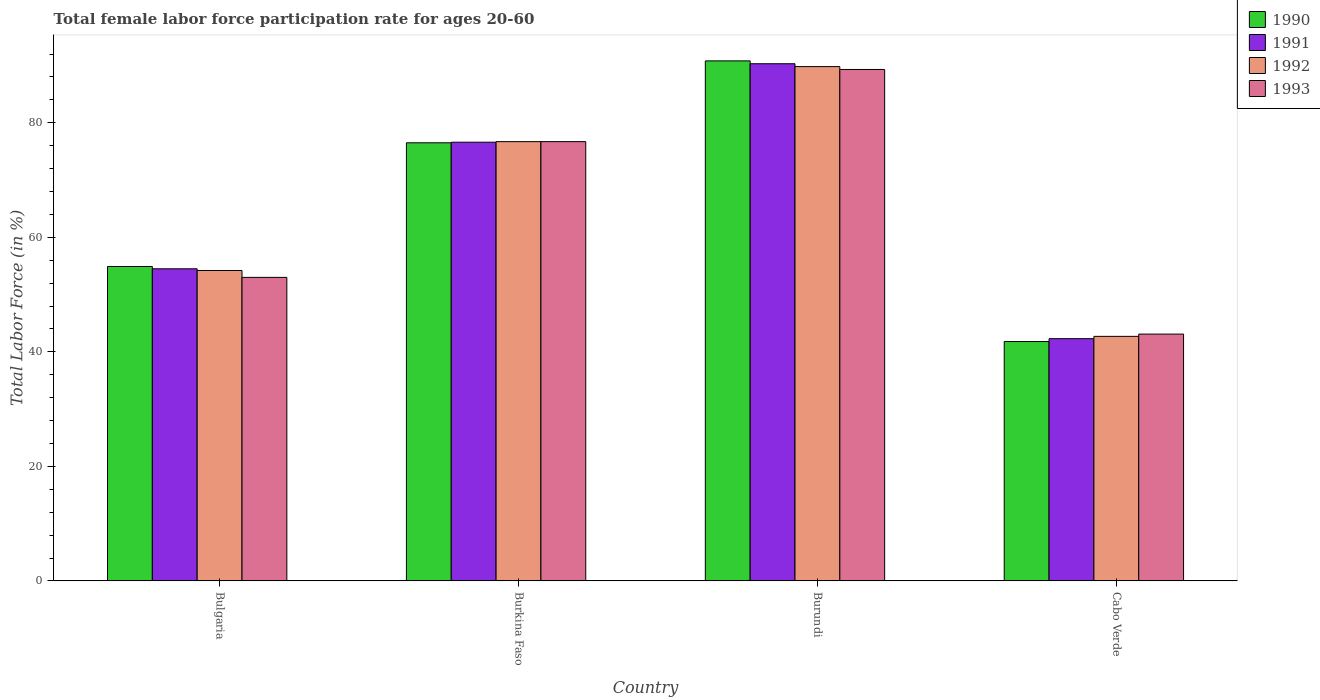Are the number of bars per tick equal to the number of legend labels?
Your answer should be very brief. Yes. In how many cases, is the number of bars for a given country not equal to the number of legend labels?
Ensure brevity in your answer.  0. What is the female labor force participation rate in 1991 in Cabo Verde?
Your response must be concise. 42.3. Across all countries, what is the maximum female labor force participation rate in 1993?
Your answer should be compact. 89.3. Across all countries, what is the minimum female labor force participation rate in 1993?
Offer a very short reply. 43.1. In which country was the female labor force participation rate in 1992 maximum?
Ensure brevity in your answer.  Burundi. In which country was the female labor force participation rate in 1992 minimum?
Your answer should be very brief. Cabo Verde. What is the total female labor force participation rate in 1992 in the graph?
Your response must be concise. 263.4. What is the difference between the female labor force participation rate in 1992 in Burkina Faso and that in Cabo Verde?
Ensure brevity in your answer.  34. What is the difference between the female labor force participation rate in 1992 in Bulgaria and the female labor force participation rate in 1993 in Burkina Faso?
Keep it short and to the point. -22.5. What is the average female labor force participation rate in 1991 per country?
Ensure brevity in your answer.  65.93. In how many countries, is the female labor force participation rate in 1990 greater than 20 %?
Offer a very short reply. 4. What is the ratio of the female labor force participation rate in 1992 in Burkina Faso to that in Burundi?
Ensure brevity in your answer.  0.85. What is the difference between the highest and the second highest female labor force participation rate in 1991?
Keep it short and to the point. 13.7. What is the difference between the highest and the lowest female labor force participation rate in 1993?
Offer a terse response. 46.2. In how many countries, is the female labor force participation rate in 1993 greater than the average female labor force participation rate in 1993 taken over all countries?
Provide a succinct answer. 2. Is the sum of the female labor force participation rate in 1990 in Bulgaria and Burundi greater than the maximum female labor force participation rate in 1991 across all countries?
Make the answer very short. Yes. What does the 1st bar from the left in Bulgaria represents?
Your response must be concise. 1990. What does the 3rd bar from the right in Bulgaria represents?
Ensure brevity in your answer.  1991. Is it the case that in every country, the sum of the female labor force participation rate in 1993 and female labor force participation rate in 1990 is greater than the female labor force participation rate in 1991?
Keep it short and to the point. Yes. How many bars are there?
Keep it short and to the point. 16. How many countries are there in the graph?
Give a very brief answer. 4. What is the difference between two consecutive major ticks on the Y-axis?
Your response must be concise. 20. Where does the legend appear in the graph?
Your answer should be very brief. Top right. How are the legend labels stacked?
Offer a terse response. Vertical. What is the title of the graph?
Your answer should be compact. Total female labor force participation rate for ages 20-60. Does "2009" appear as one of the legend labels in the graph?
Your answer should be very brief. No. What is the Total Labor Force (in %) in 1990 in Bulgaria?
Keep it short and to the point. 54.9. What is the Total Labor Force (in %) of 1991 in Bulgaria?
Keep it short and to the point. 54.5. What is the Total Labor Force (in %) of 1992 in Bulgaria?
Your answer should be very brief. 54.2. What is the Total Labor Force (in %) of 1993 in Bulgaria?
Ensure brevity in your answer.  53. What is the Total Labor Force (in %) of 1990 in Burkina Faso?
Your answer should be compact. 76.5. What is the Total Labor Force (in %) of 1991 in Burkina Faso?
Provide a short and direct response. 76.6. What is the Total Labor Force (in %) of 1992 in Burkina Faso?
Keep it short and to the point. 76.7. What is the Total Labor Force (in %) of 1993 in Burkina Faso?
Your answer should be compact. 76.7. What is the Total Labor Force (in %) of 1990 in Burundi?
Provide a succinct answer. 90.8. What is the Total Labor Force (in %) of 1991 in Burundi?
Ensure brevity in your answer.  90.3. What is the Total Labor Force (in %) of 1992 in Burundi?
Give a very brief answer. 89.8. What is the Total Labor Force (in %) of 1993 in Burundi?
Your response must be concise. 89.3. What is the Total Labor Force (in %) of 1990 in Cabo Verde?
Give a very brief answer. 41.8. What is the Total Labor Force (in %) in 1991 in Cabo Verde?
Your answer should be very brief. 42.3. What is the Total Labor Force (in %) in 1992 in Cabo Verde?
Ensure brevity in your answer.  42.7. What is the Total Labor Force (in %) of 1993 in Cabo Verde?
Offer a terse response. 43.1. Across all countries, what is the maximum Total Labor Force (in %) in 1990?
Give a very brief answer. 90.8. Across all countries, what is the maximum Total Labor Force (in %) in 1991?
Ensure brevity in your answer.  90.3. Across all countries, what is the maximum Total Labor Force (in %) in 1992?
Keep it short and to the point. 89.8. Across all countries, what is the maximum Total Labor Force (in %) of 1993?
Offer a terse response. 89.3. Across all countries, what is the minimum Total Labor Force (in %) in 1990?
Make the answer very short. 41.8. Across all countries, what is the minimum Total Labor Force (in %) of 1991?
Offer a very short reply. 42.3. Across all countries, what is the minimum Total Labor Force (in %) of 1992?
Give a very brief answer. 42.7. Across all countries, what is the minimum Total Labor Force (in %) of 1993?
Offer a very short reply. 43.1. What is the total Total Labor Force (in %) of 1990 in the graph?
Offer a terse response. 264. What is the total Total Labor Force (in %) of 1991 in the graph?
Provide a succinct answer. 263.7. What is the total Total Labor Force (in %) in 1992 in the graph?
Offer a very short reply. 263.4. What is the total Total Labor Force (in %) of 1993 in the graph?
Your answer should be compact. 262.1. What is the difference between the Total Labor Force (in %) of 1990 in Bulgaria and that in Burkina Faso?
Offer a very short reply. -21.6. What is the difference between the Total Labor Force (in %) in 1991 in Bulgaria and that in Burkina Faso?
Your answer should be very brief. -22.1. What is the difference between the Total Labor Force (in %) in 1992 in Bulgaria and that in Burkina Faso?
Offer a terse response. -22.5. What is the difference between the Total Labor Force (in %) in 1993 in Bulgaria and that in Burkina Faso?
Make the answer very short. -23.7. What is the difference between the Total Labor Force (in %) in 1990 in Bulgaria and that in Burundi?
Provide a short and direct response. -35.9. What is the difference between the Total Labor Force (in %) in 1991 in Bulgaria and that in Burundi?
Offer a terse response. -35.8. What is the difference between the Total Labor Force (in %) of 1992 in Bulgaria and that in Burundi?
Ensure brevity in your answer.  -35.6. What is the difference between the Total Labor Force (in %) of 1993 in Bulgaria and that in Burundi?
Make the answer very short. -36.3. What is the difference between the Total Labor Force (in %) in 1991 in Bulgaria and that in Cabo Verde?
Offer a terse response. 12.2. What is the difference between the Total Labor Force (in %) of 1992 in Bulgaria and that in Cabo Verde?
Keep it short and to the point. 11.5. What is the difference between the Total Labor Force (in %) in 1990 in Burkina Faso and that in Burundi?
Your answer should be compact. -14.3. What is the difference between the Total Labor Force (in %) in 1991 in Burkina Faso and that in Burundi?
Your answer should be compact. -13.7. What is the difference between the Total Labor Force (in %) in 1993 in Burkina Faso and that in Burundi?
Give a very brief answer. -12.6. What is the difference between the Total Labor Force (in %) of 1990 in Burkina Faso and that in Cabo Verde?
Your answer should be compact. 34.7. What is the difference between the Total Labor Force (in %) in 1991 in Burkina Faso and that in Cabo Verde?
Offer a very short reply. 34.3. What is the difference between the Total Labor Force (in %) in 1993 in Burkina Faso and that in Cabo Verde?
Make the answer very short. 33.6. What is the difference between the Total Labor Force (in %) of 1990 in Burundi and that in Cabo Verde?
Your answer should be compact. 49. What is the difference between the Total Labor Force (in %) in 1992 in Burundi and that in Cabo Verde?
Keep it short and to the point. 47.1. What is the difference between the Total Labor Force (in %) in 1993 in Burundi and that in Cabo Verde?
Keep it short and to the point. 46.2. What is the difference between the Total Labor Force (in %) of 1990 in Bulgaria and the Total Labor Force (in %) of 1991 in Burkina Faso?
Your response must be concise. -21.7. What is the difference between the Total Labor Force (in %) of 1990 in Bulgaria and the Total Labor Force (in %) of 1992 in Burkina Faso?
Your response must be concise. -21.8. What is the difference between the Total Labor Force (in %) in 1990 in Bulgaria and the Total Labor Force (in %) in 1993 in Burkina Faso?
Provide a short and direct response. -21.8. What is the difference between the Total Labor Force (in %) in 1991 in Bulgaria and the Total Labor Force (in %) in 1992 in Burkina Faso?
Ensure brevity in your answer.  -22.2. What is the difference between the Total Labor Force (in %) of 1991 in Bulgaria and the Total Labor Force (in %) of 1993 in Burkina Faso?
Your answer should be compact. -22.2. What is the difference between the Total Labor Force (in %) of 1992 in Bulgaria and the Total Labor Force (in %) of 1993 in Burkina Faso?
Provide a succinct answer. -22.5. What is the difference between the Total Labor Force (in %) in 1990 in Bulgaria and the Total Labor Force (in %) in 1991 in Burundi?
Your answer should be compact. -35.4. What is the difference between the Total Labor Force (in %) of 1990 in Bulgaria and the Total Labor Force (in %) of 1992 in Burundi?
Provide a succinct answer. -34.9. What is the difference between the Total Labor Force (in %) in 1990 in Bulgaria and the Total Labor Force (in %) in 1993 in Burundi?
Make the answer very short. -34.4. What is the difference between the Total Labor Force (in %) in 1991 in Bulgaria and the Total Labor Force (in %) in 1992 in Burundi?
Offer a terse response. -35.3. What is the difference between the Total Labor Force (in %) in 1991 in Bulgaria and the Total Labor Force (in %) in 1993 in Burundi?
Your answer should be compact. -34.8. What is the difference between the Total Labor Force (in %) in 1992 in Bulgaria and the Total Labor Force (in %) in 1993 in Burundi?
Offer a very short reply. -35.1. What is the difference between the Total Labor Force (in %) in 1990 in Bulgaria and the Total Labor Force (in %) in 1991 in Cabo Verde?
Make the answer very short. 12.6. What is the difference between the Total Labor Force (in %) of 1990 in Bulgaria and the Total Labor Force (in %) of 1992 in Cabo Verde?
Your response must be concise. 12.2. What is the difference between the Total Labor Force (in %) of 1992 in Bulgaria and the Total Labor Force (in %) of 1993 in Cabo Verde?
Your answer should be compact. 11.1. What is the difference between the Total Labor Force (in %) of 1990 in Burkina Faso and the Total Labor Force (in %) of 1992 in Burundi?
Offer a very short reply. -13.3. What is the difference between the Total Labor Force (in %) of 1990 in Burkina Faso and the Total Labor Force (in %) of 1993 in Burundi?
Ensure brevity in your answer.  -12.8. What is the difference between the Total Labor Force (in %) in 1991 in Burkina Faso and the Total Labor Force (in %) in 1992 in Burundi?
Your answer should be very brief. -13.2. What is the difference between the Total Labor Force (in %) of 1990 in Burkina Faso and the Total Labor Force (in %) of 1991 in Cabo Verde?
Your response must be concise. 34.2. What is the difference between the Total Labor Force (in %) in 1990 in Burkina Faso and the Total Labor Force (in %) in 1992 in Cabo Verde?
Your answer should be very brief. 33.8. What is the difference between the Total Labor Force (in %) of 1990 in Burkina Faso and the Total Labor Force (in %) of 1993 in Cabo Verde?
Ensure brevity in your answer.  33.4. What is the difference between the Total Labor Force (in %) in 1991 in Burkina Faso and the Total Labor Force (in %) in 1992 in Cabo Verde?
Your answer should be compact. 33.9. What is the difference between the Total Labor Force (in %) of 1991 in Burkina Faso and the Total Labor Force (in %) of 1993 in Cabo Verde?
Keep it short and to the point. 33.5. What is the difference between the Total Labor Force (in %) in 1992 in Burkina Faso and the Total Labor Force (in %) in 1993 in Cabo Verde?
Give a very brief answer. 33.6. What is the difference between the Total Labor Force (in %) in 1990 in Burundi and the Total Labor Force (in %) in 1991 in Cabo Verde?
Provide a succinct answer. 48.5. What is the difference between the Total Labor Force (in %) in 1990 in Burundi and the Total Labor Force (in %) in 1992 in Cabo Verde?
Provide a short and direct response. 48.1. What is the difference between the Total Labor Force (in %) in 1990 in Burundi and the Total Labor Force (in %) in 1993 in Cabo Verde?
Provide a succinct answer. 47.7. What is the difference between the Total Labor Force (in %) of 1991 in Burundi and the Total Labor Force (in %) of 1992 in Cabo Verde?
Your response must be concise. 47.6. What is the difference between the Total Labor Force (in %) in 1991 in Burundi and the Total Labor Force (in %) in 1993 in Cabo Verde?
Your answer should be compact. 47.2. What is the difference between the Total Labor Force (in %) of 1992 in Burundi and the Total Labor Force (in %) of 1993 in Cabo Verde?
Offer a very short reply. 46.7. What is the average Total Labor Force (in %) in 1990 per country?
Ensure brevity in your answer.  66. What is the average Total Labor Force (in %) of 1991 per country?
Offer a very short reply. 65.92. What is the average Total Labor Force (in %) in 1992 per country?
Provide a short and direct response. 65.85. What is the average Total Labor Force (in %) in 1993 per country?
Your answer should be compact. 65.53. What is the difference between the Total Labor Force (in %) in 1990 and Total Labor Force (in %) in 1991 in Bulgaria?
Your answer should be compact. 0.4. What is the difference between the Total Labor Force (in %) in 1990 and Total Labor Force (in %) in 1992 in Bulgaria?
Ensure brevity in your answer.  0.7. What is the difference between the Total Labor Force (in %) of 1992 and Total Labor Force (in %) of 1993 in Bulgaria?
Make the answer very short. 1.2. What is the difference between the Total Labor Force (in %) in 1990 and Total Labor Force (in %) in 1991 in Burkina Faso?
Offer a very short reply. -0.1. What is the difference between the Total Labor Force (in %) in 1990 and Total Labor Force (in %) in 1992 in Burkina Faso?
Offer a very short reply. -0.2. What is the difference between the Total Labor Force (in %) in 1990 and Total Labor Force (in %) in 1993 in Burkina Faso?
Ensure brevity in your answer.  -0.2. What is the difference between the Total Labor Force (in %) in 1991 and Total Labor Force (in %) in 1993 in Burkina Faso?
Your response must be concise. -0.1. What is the difference between the Total Labor Force (in %) of 1992 and Total Labor Force (in %) of 1993 in Burkina Faso?
Provide a short and direct response. 0. What is the difference between the Total Labor Force (in %) in 1991 and Total Labor Force (in %) in 1992 in Burundi?
Your answer should be compact. 0.5. What is the difference between the Total Labor Force (in %) in 1992 and Total Labor Force (in %) in 1993 in Burundi?
Your answer should be very brief. 0.5. What is the difference between the Total Labor Force (in %) in 1990 and Total Labor Force (in %) in 1992 in Cabo Verde?
Keep it short and to the point. -0.9. What is the difference between the Total Labor Force (in %) in 1990 and Total Labor Force (in %) in 1993 in Cabo Verde?
Your answer should be very brief. -1.3. What is the difference between the Total Labor Force (in %) in 1991 and Total Labor Force (in %) in 1992 in Cabo Verde?
Keep it short and to the point. -0.4. What is the difference between the Total Labor Force (in %) of 1991 and Total Labor Force (in %) of 1993 in Cabo Verde?
Your response must be concise. -0.8. What is the ratio of the Total Labor Force (in %) of 1990 in Bulgaria to that in Burkina Faso?
Ensure brevity in your answer.  0.72. What is the ratio of the Total Labor Force (in %) of 1991 in Bulgaria to that in Burkina Faso?
Give a very brief answer. 0.71. What is the ratio of the Total Labor Force (in %) in 1992 in Bulgaria to that in Burkina Faso?
Give a very brief answer. 0.71. What is the ratio of the Total Labor Force (in %) of 1993 in Bulgaria to that in Burkina Faso?
Your answer should be compact. 0.69. What is the ratio of the Total Labor Force (in %) of 1990 in Bulgaria to that in Burundi?
Your answer should be very brief. 0.6. What is the ratio of the Total Labor Force (in %) in 1991 in Bulgaria to that in Burundi?
Your answer should be very brief. 0.6. What is the ratio of the Total Labor Force (in %) of 1992 in Bulgaria to that in Burundi?
Offer a terse response. 0.6. What is the ratio of the Total Labor Force (in %) of 1993 in Bulgaria to that in Burundi?
Make the answer very short. 0.59. What is the ratio of the Total Labor Force (in %) of 1990 in Bulgaria to that in Cabo Verde?
Make the answer very short. 1.31. What is the ratio of the Total Labor Force (in %) in 1991 in Bulgaria to that in Cabo Verde?
Your answer should be very brief. 1.29. What is the ratio of the Total Labor Force (in %) of 1992 in Bulgaria to that in Cabo Verde?
Keep it short and to the point. 1.27. What is the ratio of the Total Labor Force (in %) of 1993 in Bulgaria to that in Cabo Verde?
Provide a short and direct response. 1.23. What is the ratio of the Total Labor Force (in %) of 1990 in Burkina Faso to that in Burundi?
Provide a succinct answer. 0.84. What is the ratio of the Total Labor Force (in %) in 1991 in Burkina Faso to that in Burundi?
Your response must be concise. 0.85. What is the ratio of the Total Labor Force (in %) of 1992 in Burkina Faso to that in Burundi?
Ensure brevity in your answer.  0.85. What is the ratio of the Total Labor Force (in %) in 1993 in Burkina Faso to that in Burundi?
Make the answer very short. 0.86. What is the ratio of the Total Labor Force (in %) in 1990 in Burkina Faso to that in Cabo Verde?
Provide a short and direct response. 1.83. What is the ratio of the Total Labor Force (in %) of 1991 in Burkina Faso to that in Cabo Verde?
Provide a succinct answer. 1.81. What is the ratio of the Total Labor Force (in %) of 1992 in Burkina Faso to that in Cabo Verde?
Provide a succinct answer. 1.8. What is the ratio of the Total Labor Force (in %) in 1993 in Burkina Faso to that in Cabo Verde?
Your answer should be compact. 1.78. What is the ratio of the Total Labor Force (in %) of 1990 in Burundi to that in Cabo Verde?
Give a very brief answer. 2.17. What is the ratio of the Total Labor Force (in %) of 1991 in Burundi to that in Cabo Verde?
Your answer should be compact. 2.13. What is the ratio of the Total Labor Force (in %) of 1992 in Burundi to that in Cabo Verde?
Your answer should be very brief. 2.1. What is the ratio of the Total Labor Force (in %) in 1993 in Burundi to that in Cabo Verde?
Make the answer very short. 2.07. What is the difference between the highest and the second highest Total Labor Force (in %) of 1991?
Keep it short and to the point. 13.7. What is the difference between the highest and the second highest Total Labor Force (in %) in 1993?
Offer a very short reply. 12.6. What is the difference between the highest and the lowest Total Labor Force (in %) in 1990?
Provide a succinct answer. 49. What is the difference between the highest and the lowest Total Labor Force (in %) in 1991?
Give a very brief answer. 48. What is the difference between the highest and the lowest Total Labor Force (in %) in 1992?
Your response must be concise. 47.1. What is the difference between the highest and the lowest Total Labor Force (in %) in 1993?
Your response must be concise. 46.2. 